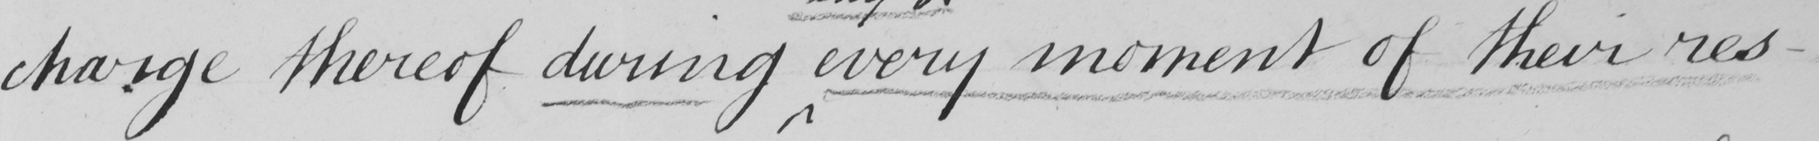Please provide the text content of this handwritten line. charge thereof during every moment of their res- 